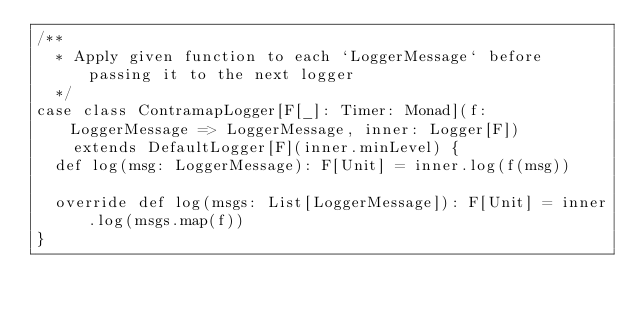Convert code to text. <code><loc_0><loc_0><loc_500><loc_500><_Scala_>/**
  * Apply given function to each `LoggerMessage` before passing it to the next logger
  */
case class ContramapLogger[F[_]: Timer: Monad](f: LoggerMessage => LoggerMessage, inner: Logger[F])
    extends DefaultLogger[F](inner.minLevel) {
  def log(msg: LoggerMessage): F[Unit] = inner.log(f(msg))

  override def log(msgs: List[LoggerMessage]): F[Unit] = inner.log(msgs.map(f))
}
</code> 